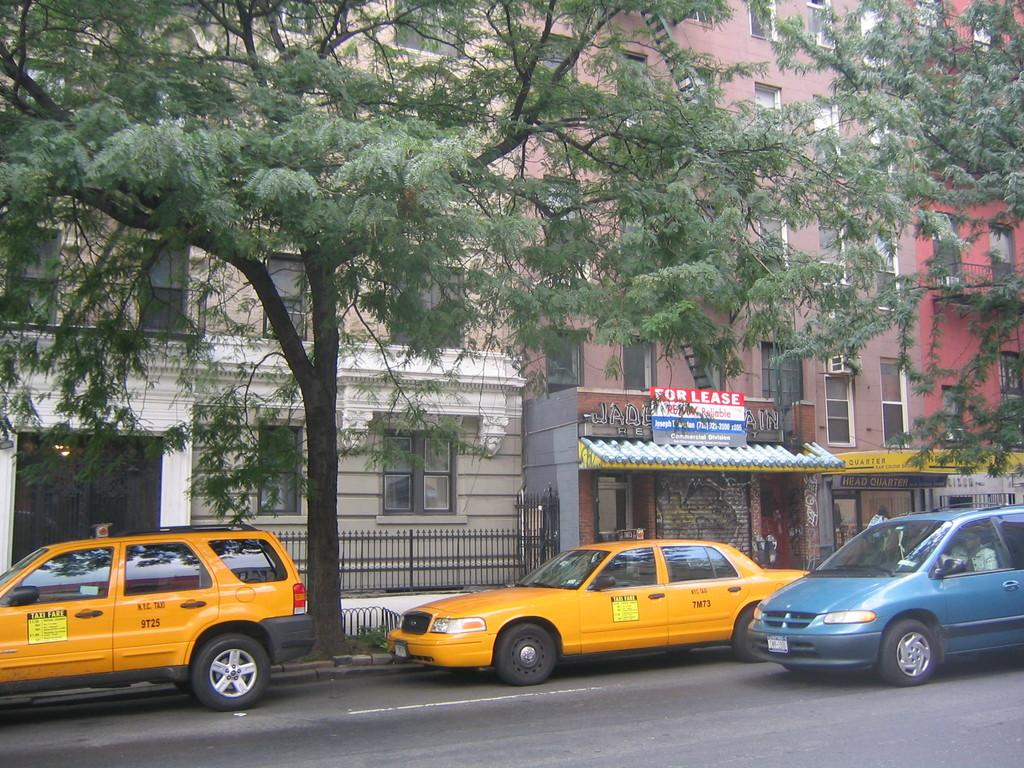<image>
Relay a brief, clear account of the picture shown. The sign with the words For Lease at the top of it. 